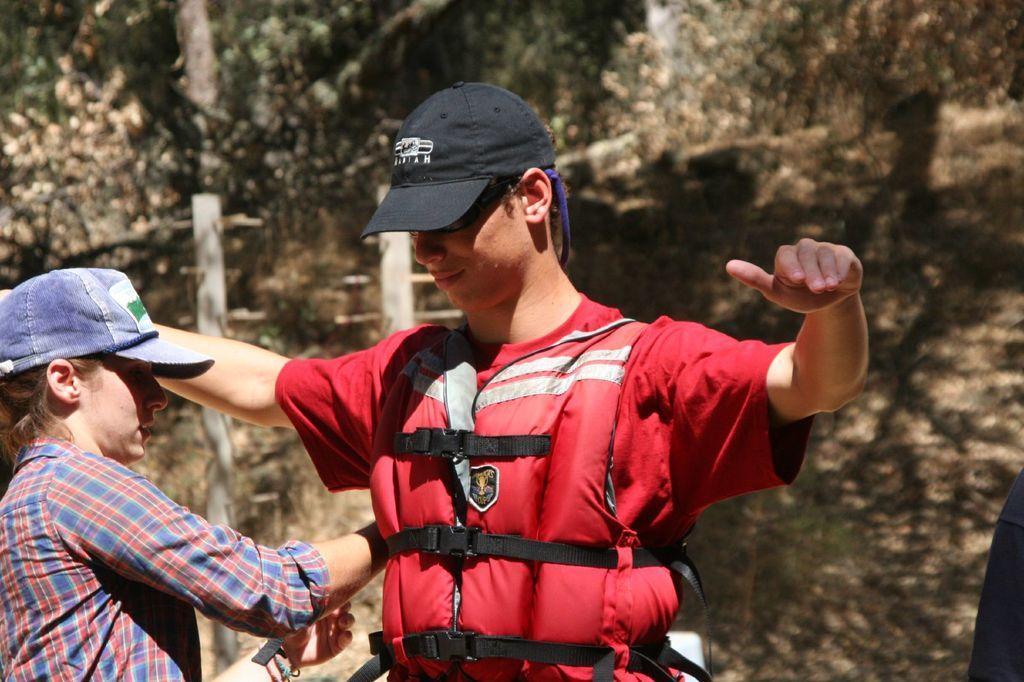Can you describe this image briefly? As we can see in the image in the front there are two people standing. The woman on the left side is wearing blue color cap, red and blue color dress. The man standing in the middle is wearing black color cap, goggles and red color jacket. 